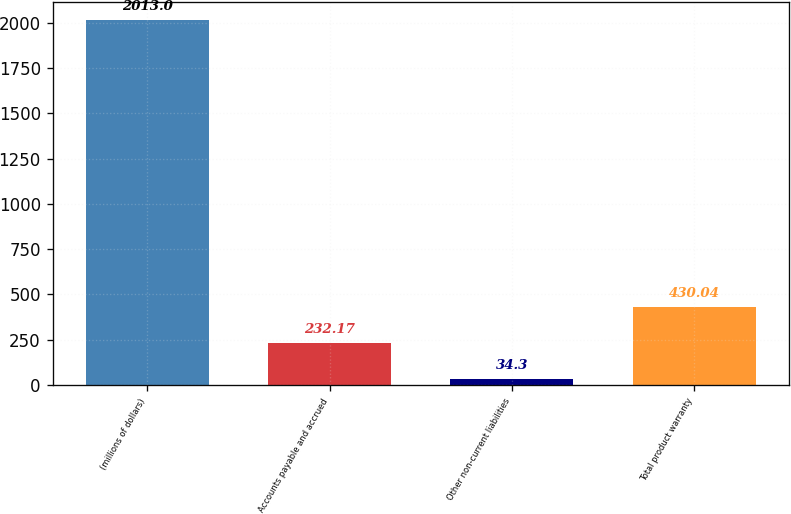Convert chart to OTSL. <chart><loc_0><loc_0><loc_500><loc_500><bar_chart><fcel>(millions of dollars)<fcel>Accounts payable and accrued<fcel>Other non-current liabilities<fcel>Total product warranty<nl><fcel>2013<fcel>232.17<fcel>34.3<fcel>430.04<nl></chart> 